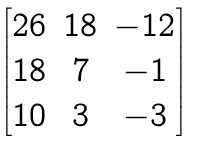Convert formula to latex. <formula><loc_0><loc_0><loc_500><loc_500>\begin{bmatrix} 2 6 & 1 8 & - 1 2 \\ 1 8 & 7 & - 1 \\ 1 0 & 3 & - 3 \end{bmatrix}</formula> 